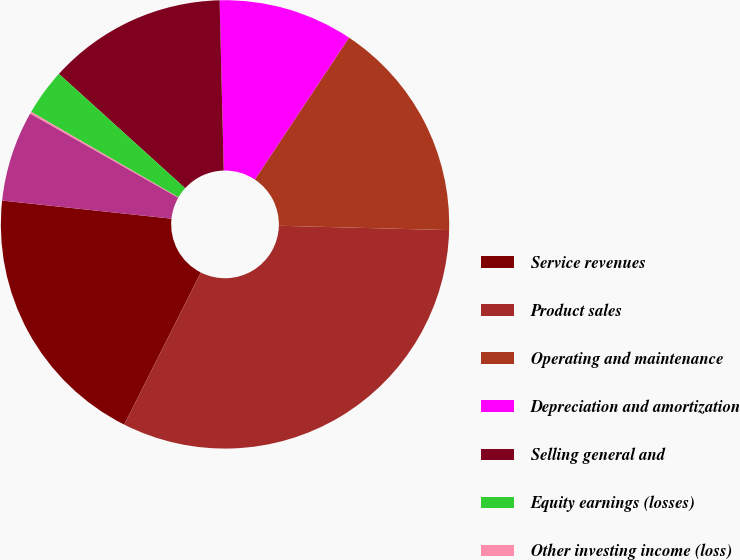Convert chart. <chart><loc_0><loc_0><loc_500><loc_500><pie_chart><fcel>Service revenues<fcel>Product sales<fcel>Operating and maintenance<fcel>Depreciation and amortization<fcel>Selling general and<fcel>Equity earnings (losses)<fcel>Other investing income (loss)<fcel>Less Net income attributable<nl><fcel>19.27%<fcel>32.02%<fcel>16.08%<fcel>9.71%<fcel>12.9%<fcel>3.34%<fcel>0.15%<fcel>6.53%<nl></chart> 